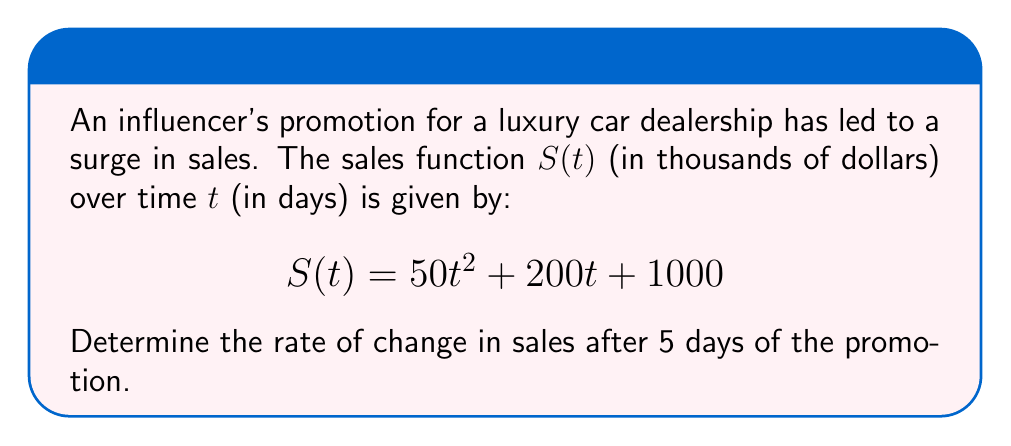Could you help me with this problem? To find the rate of change in sales at a specific point in time, we need to use the derivative of the sales function. Here's how we solve this step-by-step:

1) The sales function is $S(t) = 50t^2 + 200t + 1000$

2) To find the rate of change, we need to find $S'(t)$, the derivative of $S(t)$:
   $$S'(t) = \frac{d}{dt}(50t^2 + 200t + 1000)$$

3) Using the power rule and constant rule of differentiation:
   $$S'(t) = 100t + 200$$

4) This $S'(t)$ function represents the instantaneous rate of change of sales at any time $t$.

5) To find the rate of change after 5 days, we substitute $t = 5$ into $S'(t)$:
   $$S'(5) = 100(5) + 200 = 500 + 200 = 700$$

6) Therefore, the rate of change in sales after 5 days is 700 thousand dollars per day.
Answer: $700,000 per day 